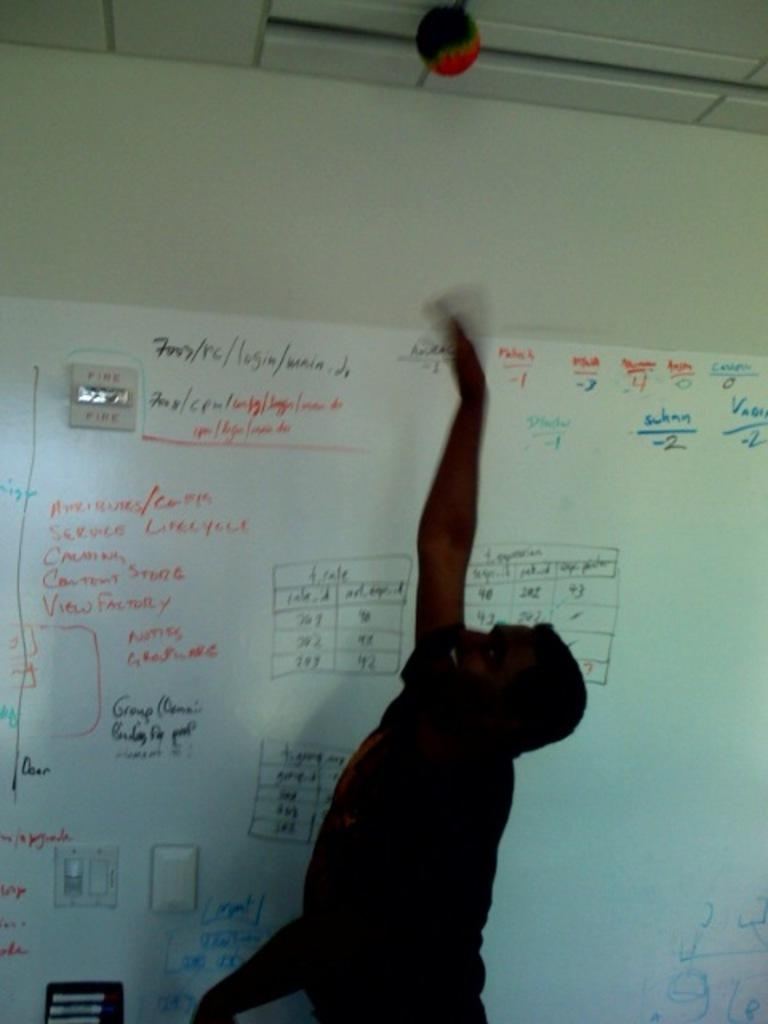<image>
Present a compact description of the photo's key features. A man throws something at the ceiling in front of a whiteboard that has a lot of writing on it, including Service and View Factory. 